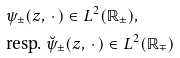<formula> <loc_0><loc_0><loc_500><loc_500>& \psi _ { \pm } ( z , \, \cdot \, ) \in L ^ { 2 } ( \mathbb { R } _ { \pm } ) , \\ & \text {resp. } \breve { \psi } _ { \pm } ( z , \, \cdot \, ) \in L ^ { 2 } ( \mathbb { R } _ { \mp } )</formula> 